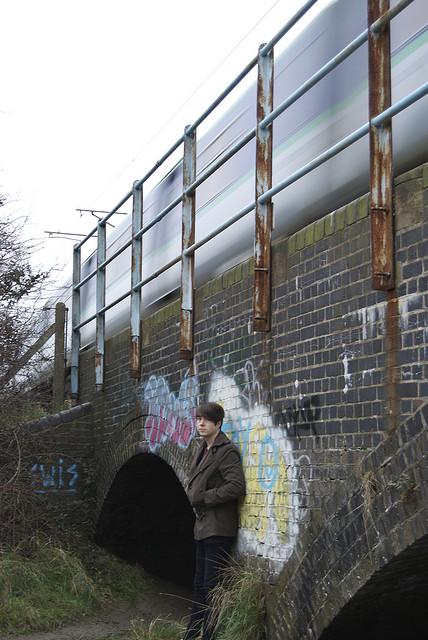Have these walls been well-respected by the community?
Short answer required. No. Does this guy look depressed?
Be succinct. Yes. What structure is he leaning against?
Concise answer only. Bridge. 